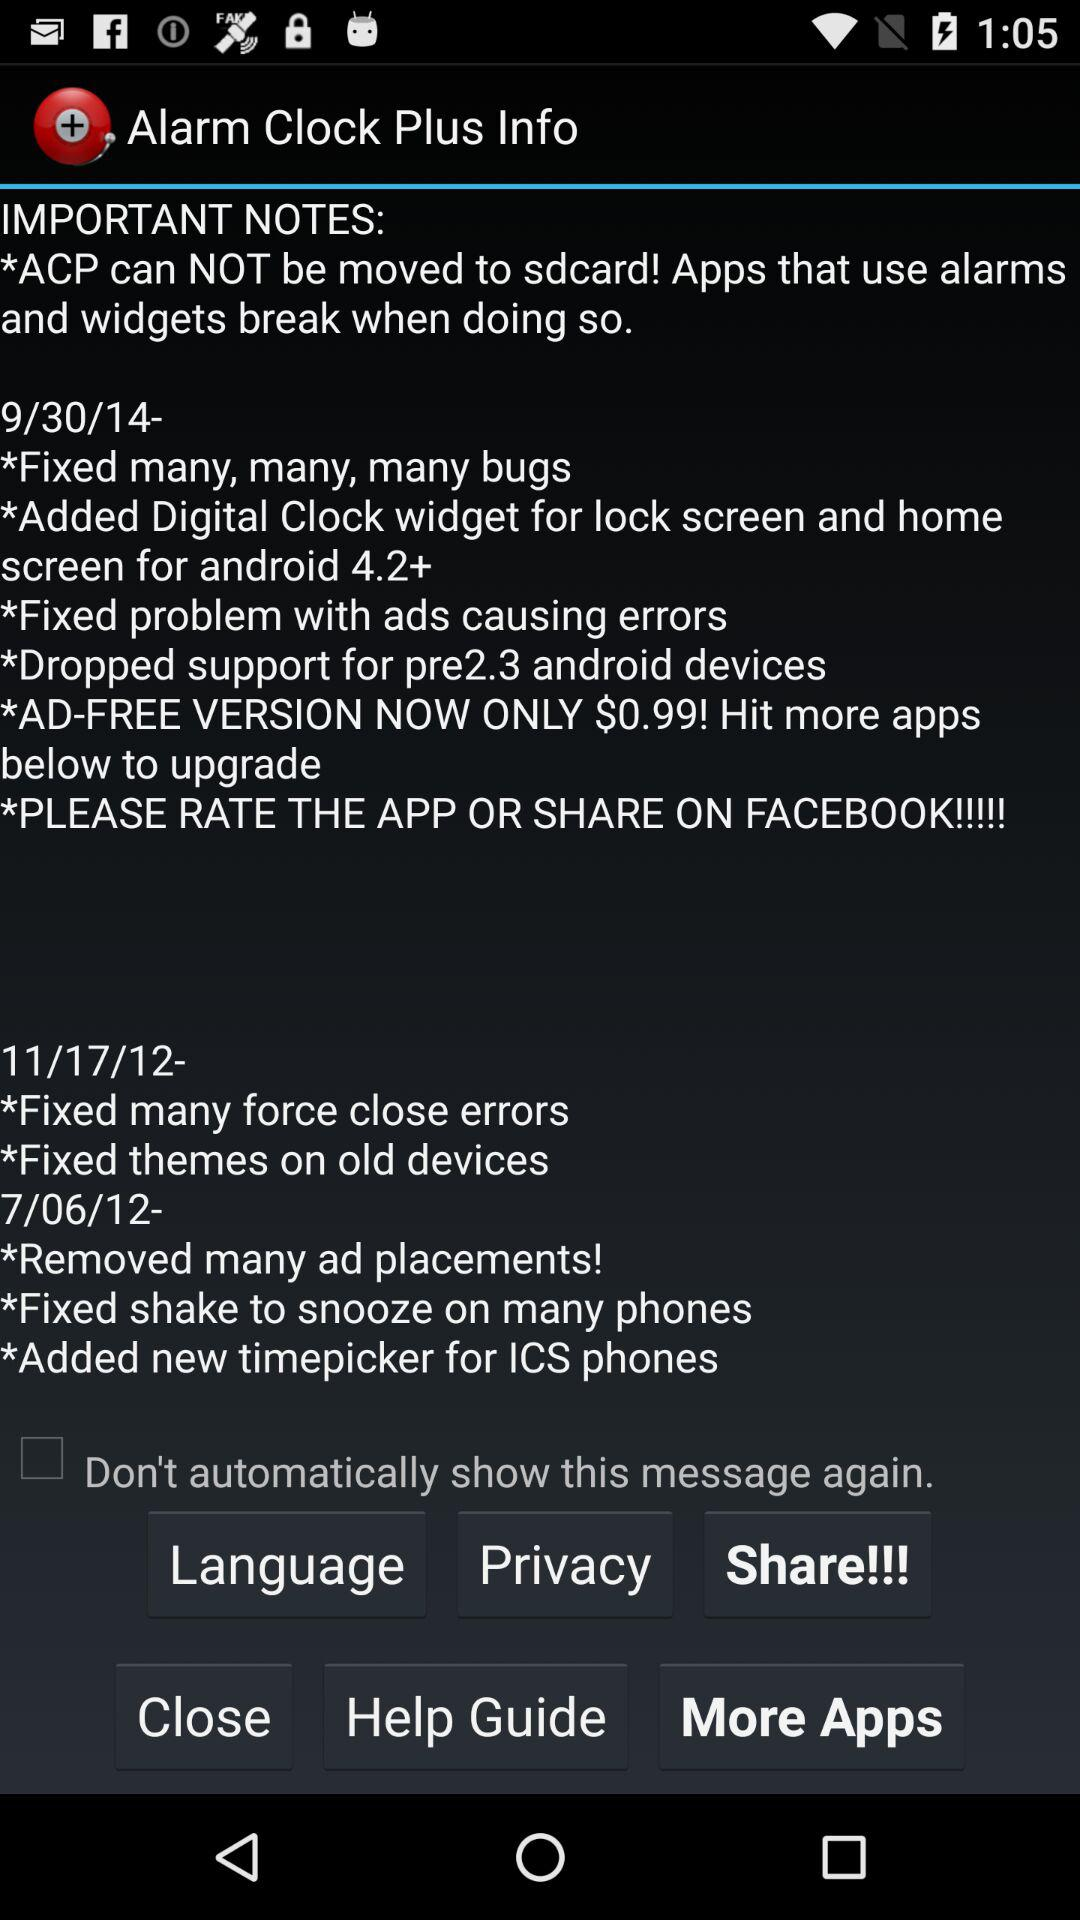What is the currency for the cost of the ad-free version of the application? The currency is $. 